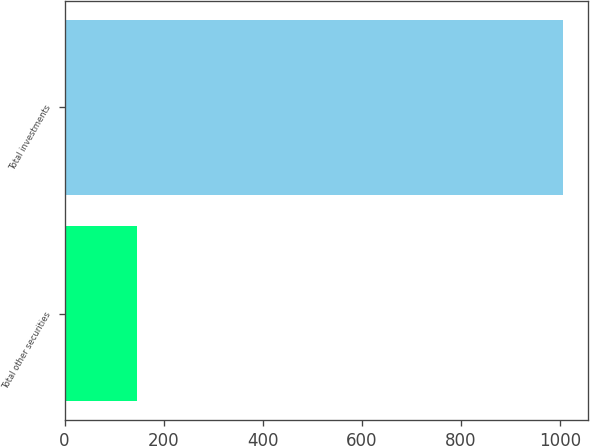<chart> <loc_0><loc_0><loc_500><loc_500><bar_chart><fcel>Total other securities<fcel>Total investments<nl><fcel>146<fcel>1006<nl></chart> 